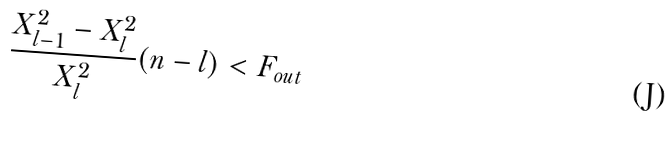Convert formula to latex. <formula><loc_0><loc_0><loc_500><loc_500>\frac { X _ { l - 1 } ^ { 2 } - X _ { l } ^ { 2 } } { X _ { l } ^ { 2 } } ( n - l ) < F _ { o u t }</formula> 